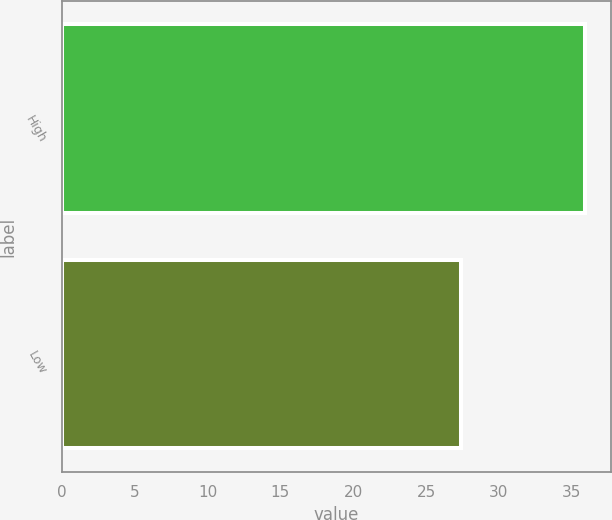<chart> <loc_0><loc_0><loc_500><loc_500><bar_chart><fcel>High<fcel>Low<nl><fcel>35.92<fcel>27.41<nl></chart> 